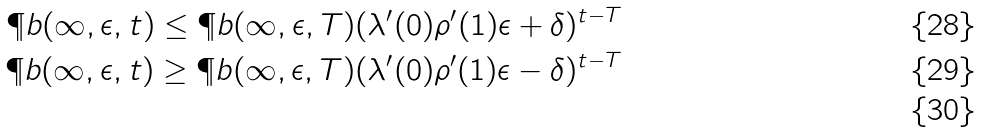Convert formula to latex. <formula><loc_0><loc_0><loc_500><loc_500>\P b ( \infty , \epsilon , t ) \leq \P b ( \infty , \epsilon , T ) ( \lambda ^ { \prime } ( 0 ) \rho ^ { \prime } ( 1 ) \epsilon + \delta ) ^ { t - T } \\ \P b ( \infty , \epsilon , t ) \geq \P b ( \infty , \epsilon , T ) ( \lambda ^ { \prime } ( 0 ) \rho ^ { \prime } ( 1 ) \epsilon - \delta ) ^ { t - T } \\</formula> 